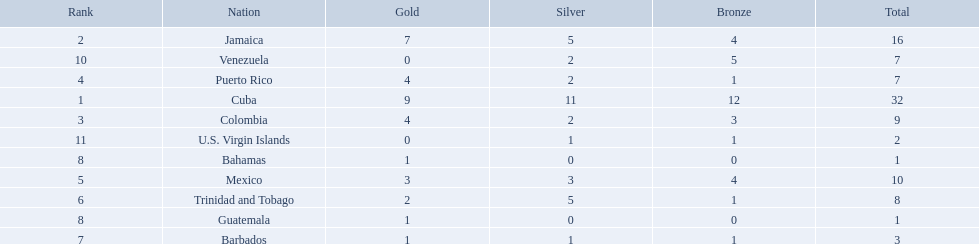Which countries competed in the 1966 central american and caribbean games? Cuba, Jamaica, Colombia, Puerto Rico, Mexico, Trinidad and Tobago, Barbados, Guatemala, Bahamas, Venezuela, U.S. Virgin Islands. Which countries won at least six silver medals at these games? Cuba. 